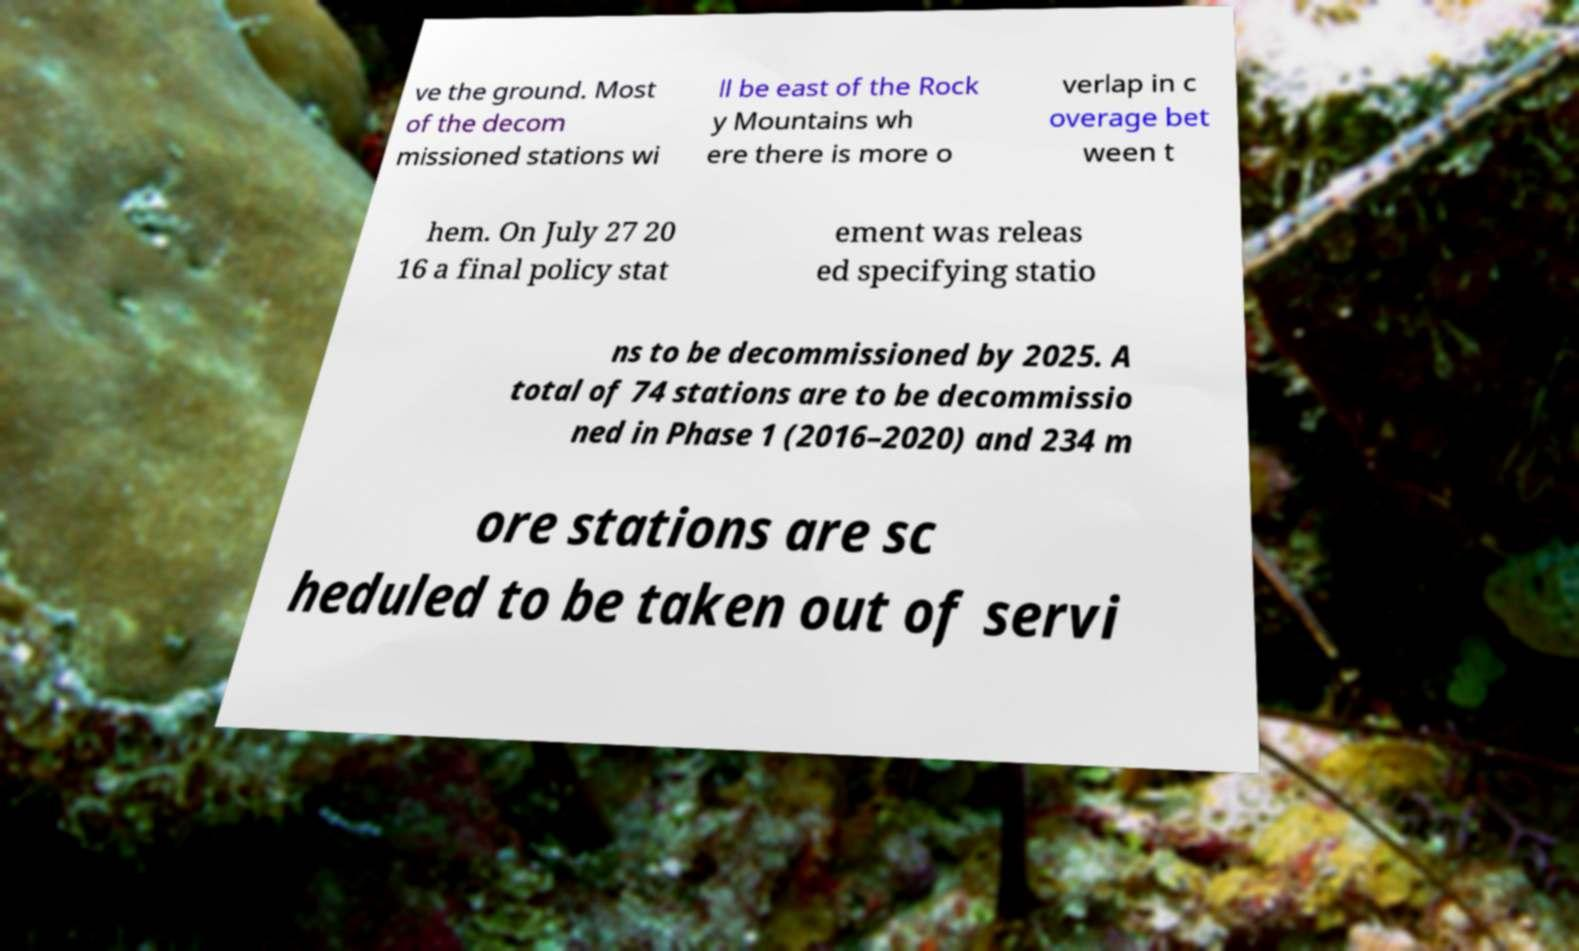Can you accurately transcribe the text from the provided image for me? ve the ground. Most of the decom missioned stations wi ll be east of the Rock y Mountains wh ere there is more o verlap in c overage bet ween t hem. On July 27 20 16 a final policy stat ement was releas ed specifying statio ns to be decommissioned by 2025. A total of 74 stations are to be decommissio ned in Phase 1 (2016–2020) and 234 m ore stations are sc heduled to be taken out of servi 